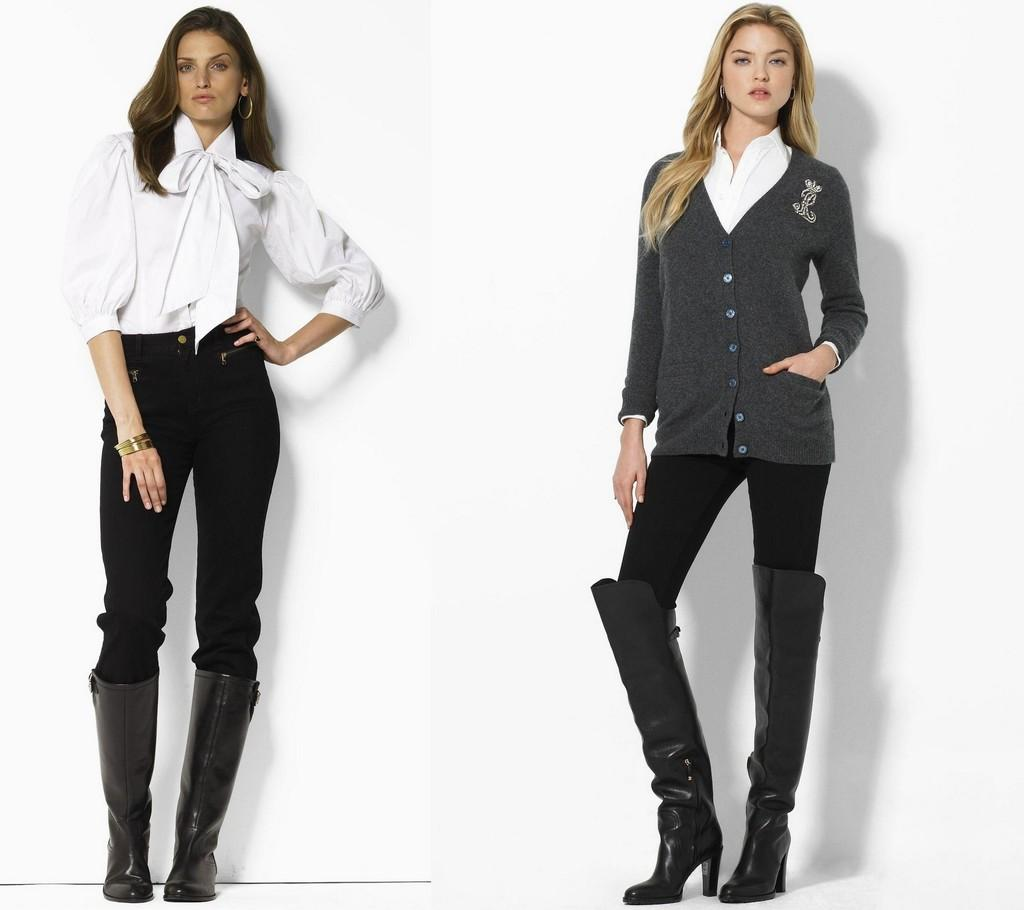How many people are in the image? There are two women in the image. What are the women doing in the image? The women are standing. What type of footwear are the women wearing? The women are wearing shoes. What type of tin can be seen in the hands of the women in the image? There is no tin present in the image; the women are not holding anything. 